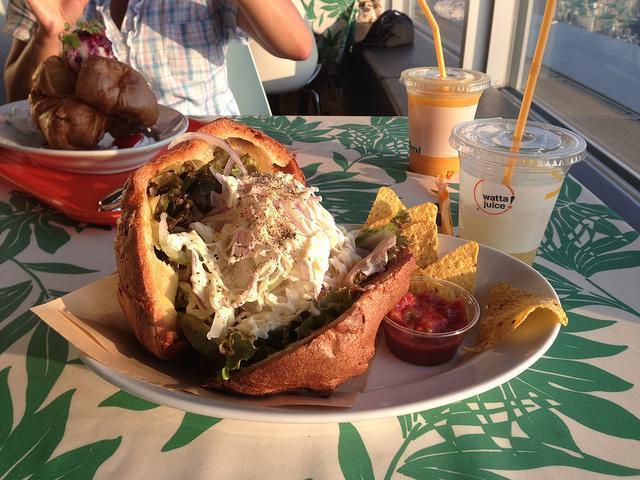How many chairs are there?
Give a very brief answer. 1. How many sandwiches are there?
Give a very brief answer. 1. How many bowls can you see?
Give a very brief answer. 3. How many cups are there?
Give a very brief answer. 2. 